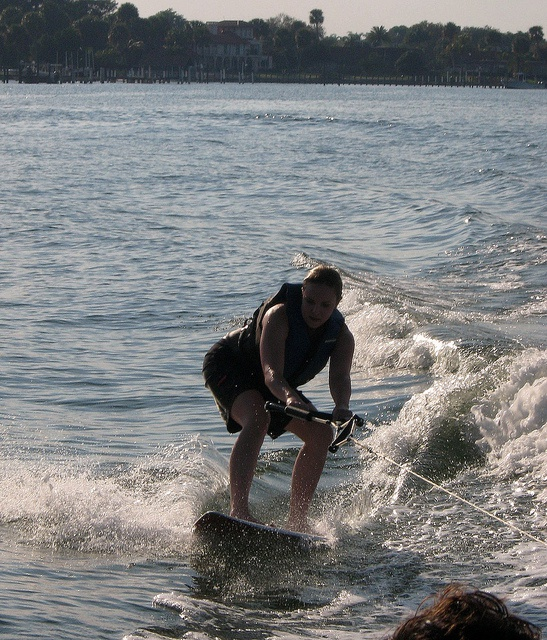Describe the objects in this image and their specific colors. I can see people in black, gray, and darkgray tones, people in black, gray, and maroon tones, and surfboard in black, gray, and darkgray tones in this image. 